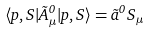Convert formula to latex. <formula><loc_0><loc_0><loc_500><loc_500>\langle p , S | \tilde { A } _ { \mu } ^ { 0 } | p , S \rangle = \tilde { a } ^ { 0 } S _ { \mu }</formula> 